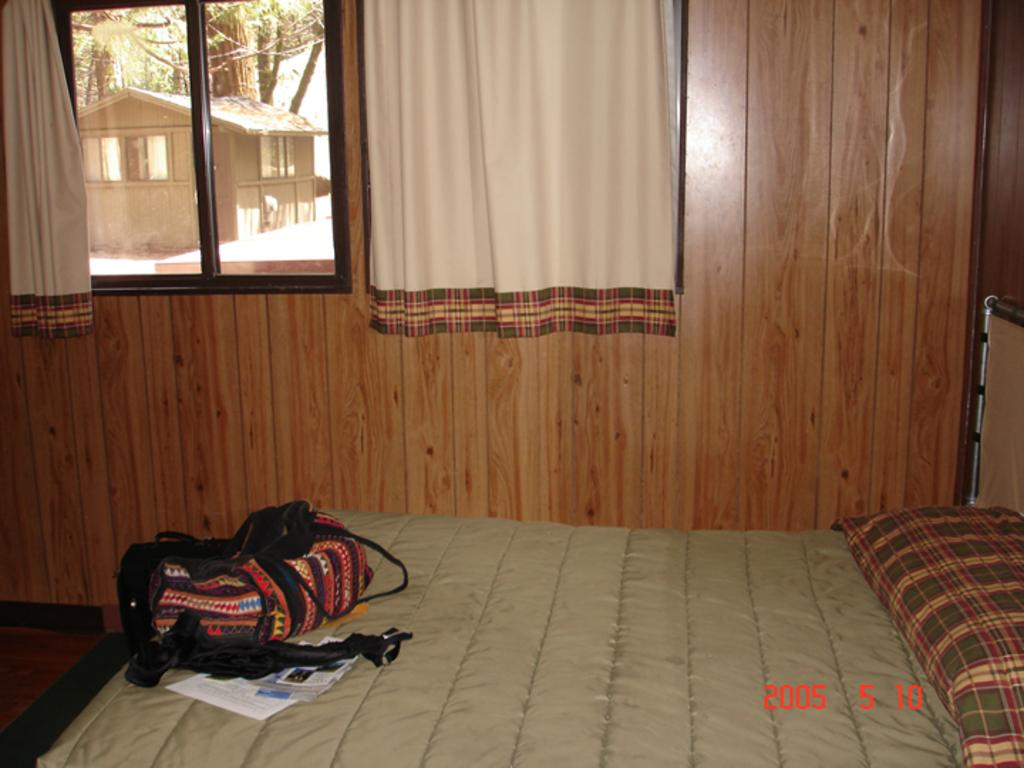What can be found in the room? There is a bag, papers, and pillows in the room. What is on the bed? There is an object on the bed. What is visible through the window? A house, windows on the house, and trees are visible through the window. What is associated with the window in the room? There are curtains associated with the window. What is on the wall in the room? There is a wall in the room. What type of copper material can be seen in the mouth of the person in the image? There is no person present in the image, and therefore no mouth or copper material can be observed. Can you describe the airplane visible through the window in the image? There is no airplane visible through the window in the image; only a house, windows on the house, and trees are visible. 